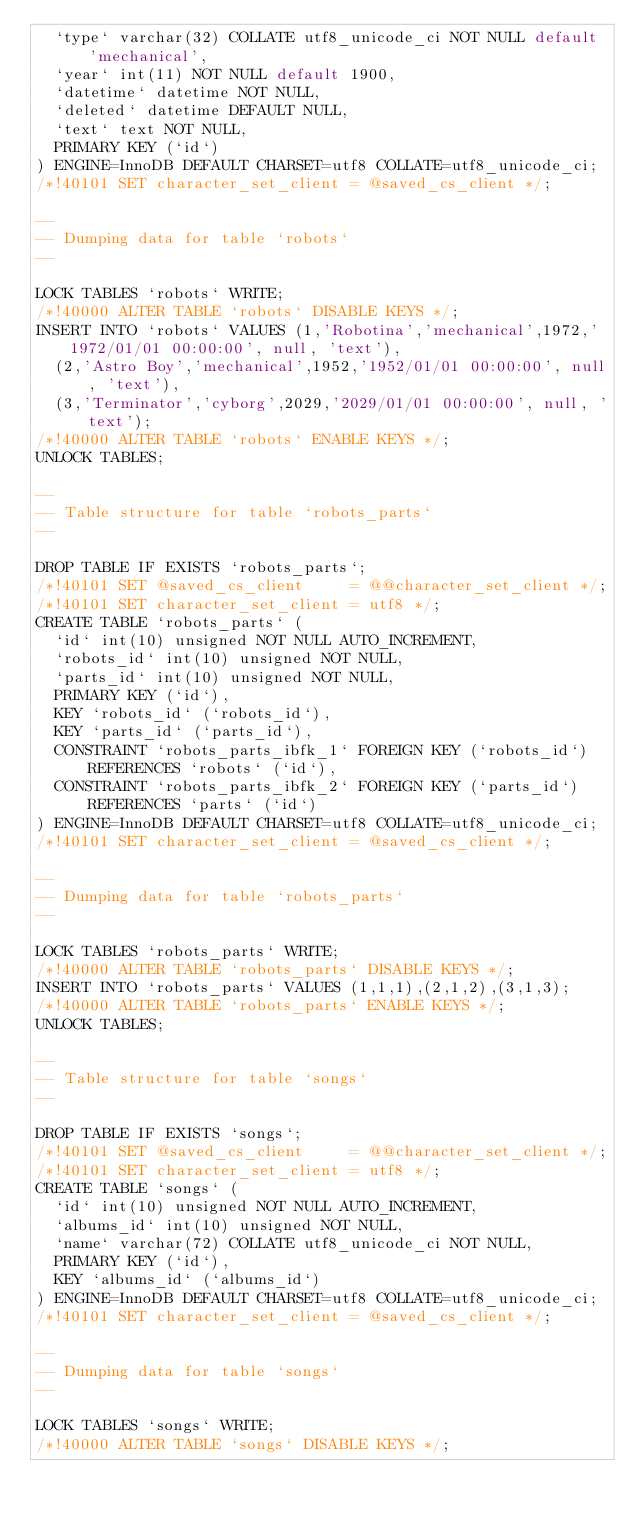<code> <loc_0><loc_0><loc_500><loc_500><_SQL_>  `type` varchar(32) COLLATE utf8_unicode_ci NOT NULL default 'mechanical',
  `year` int(11) NOT NULL default 1900,
  `datetime` datetime NOT NULL,
  `deleted` datetime DEFAULT NULL,
  `text` text NOT NULL,
  PRIMARY KEY (`id`)
) ENGINE=InnoDB DEFAULT CHARSET=utf8 COLLATE=utf8_unicode_ci;
/*!40101 SET character_set_client = @saved_cs_client */;

--
-- Dumping data for table `robots`
--

LOCK TABLES `robots` WRITE;
/*!40000 ALTER TABLE `robots` DISABLE KEYS */;
INSERT INTO `robots` VALUES (1,'Robotina','mechanical',1972,'1972/01/01 00:00:00', null, 'text'),
  (2,'Astro Boy','mechanical',1952,'1952/01/01 00:00:00', null, 'text'),
  (3,'Terminator','cyborg',2029,'2029/01/01 00:00:00', null, 'text');
/*!40000 ALTER TABLE `robots` ENABLE KEYS */;
UNLOCK TABLES;

--
-- Table structure for table `robots_parts`
--

DROP TABLE IF EXISTS `robots_parts`;
/*!40101 SET @saved_cs_client     = @@character_set_client */;
/*!40101 SET character_set_client = utf8 */;
CREATE TABLE `robots_parts` (
  `id` int(10) unsigned NOT NULL AUTO_INCREMENT,
  `robots_id` int(10) unsigned NOT NULL,
  `parts_id` int(10) unsigned NOT NULL,
  PRIMARY KEY (`id`),
  KEY `robots_id` (`robots_id`),
  KEY `parts_id` (`parts_id`),
  CONSTRAINT `robots_parts_ibfk_1` FOREIGN KEY (`robots_id`) REFERENCES `robots` (`id`),
  CONSTRAINT `robots_parts_ibfk_2` FOREIGN KEY (`parts_id`) REFERENCES `parts` (`id`)
) ENGINE=InnoDB DEFAULT CHARSET=utf8 COLLATE=utf8_unicode_ci;
/*!40101 SET character_set_client = @saved_cs_client */;

--
-- Dumping data for table `robots_parts`
--

LOCK TABLES `robots_parts` WRITE;
/*!40000 ALTER TABLE `robots_parts` DISABLE KEYS */;
INSERT INTO `robots_parts` VALUES (1,1,1),(2,1,2),(3,1,3);
/*!40000 ALTER TABLE `robots_parts` ENABLE KEYS */;
UNLOCK TABLES;

--
-- Table structure for table `songs`
--

DROP TABLE IF EXISTS `songs`;
/*!40101 SET @saved_cs_client     = @@character_set_client */;
/*!40101 SET character_set_client = utf8 */;
CREATE TABLE `songs` (
  `id` int(10) unsigned NOT NULL AUTO_INCREMENT,
  `albums_id` int(10) unsigned NOT NULL,
  `name` varchar(72) COLLATE utf8_unicode_ci NOT NULL,
  PRIMARY KEY (`id`),
  KEY `albums_id` (`albums_id`)
) ENGINE=InnoDB DEFAULT CHARSET=utf8 COLLATE=utf8_unicode_ci;
/*!40101 SET character_set_client = @saved_cs_client */;

--
-- Dumping data for table `songs`
--

LOCK TABLES `songs` WRITE;
/*!40000 ALTER TABLE `songs` DISABLE KEYS */;</code> 